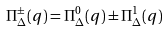<formula> <loc_0><loc_0><loc_500><loc_500>\Pi _ { \Delta } ^ { \pm } ( q ) = \Pi _ { \Delta } ^ { 0 } ( q ) \pm \Pi _ { \Delta } ^ { 1 } ( q )</formula> 